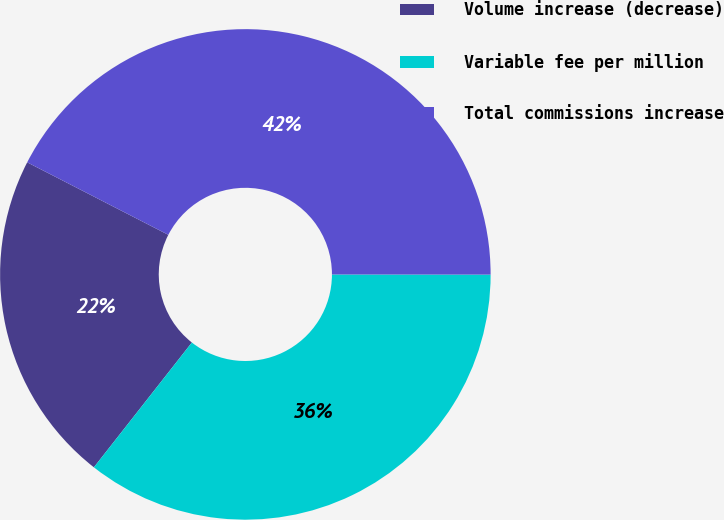Convert chart to OTSL. <chart><loc_0><loc_0><loc_500><loc_500><pie_chart><fcel>Volume increase (decrease)<fcel>Variable fee per million<fcel>Total commissions increase<nl><fcel>21.96%<fcel>35.58%<fcel>42.46%<nl></chart> 